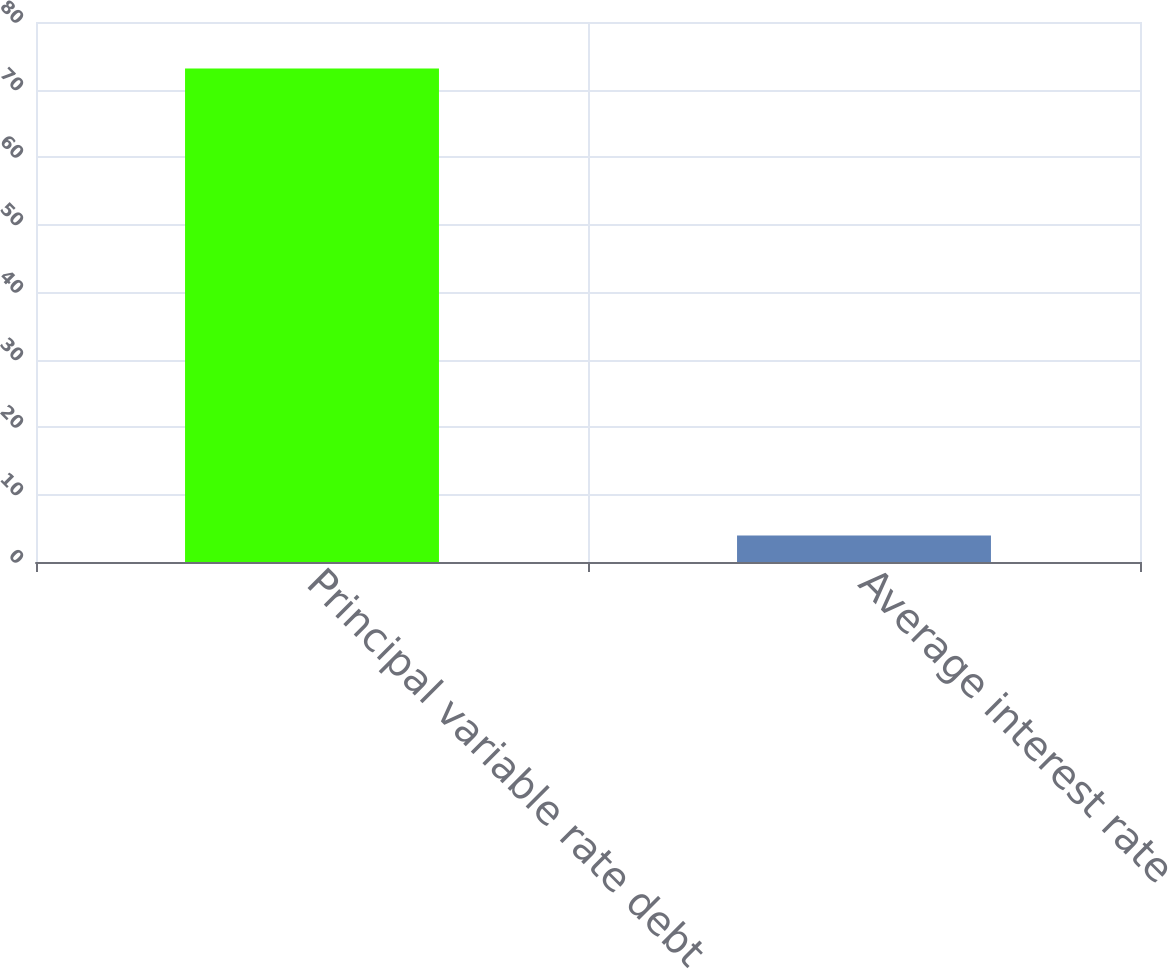Convert chart. <chart><loc_0><loc_0><loc_500><loc_500><bar_chart><fcel>Principal variable rate debt<fcel>Average interest rate<nl><fcel>73.1<fcel>3.91<nl></chart> 